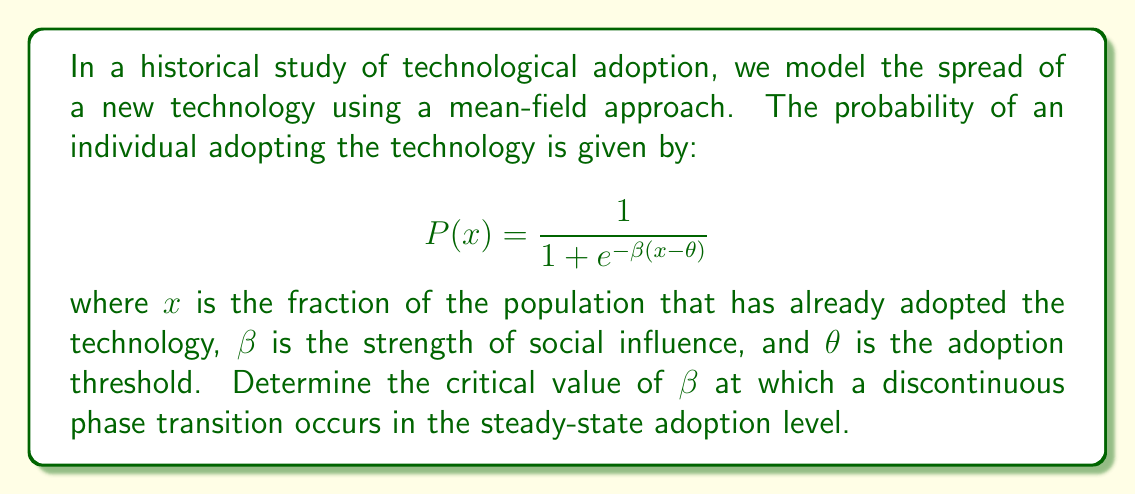Show me your answer to this math problem. To find the critical value of $\beta$, we follow these steps:

1) In the steady state, the fraction of adopters $x$ must satisfy:

   $$x = P(x) = \frac{1}{1 + e^{-\beta(x-\theta)}}$$

2) This equation can have multiple solutions, indicating a phase transition. To find the critical point, we need to find when the curve $y = P(x)$ just touches the line $y = x$.

3) This occurs when:
   
   $$\frac{dP}{dx} = 1$$

4) We calculate $\frac{dP}{dx}$:

   $$\frac{dP}{dx} = \frac{\beta e^{-\beta(x-\theta)}}{(1 + e^{-\beta(x-\theta)})^2}$$

5) At the critical point, this equals 1:

   $$\frac{\beta e^{-\beta(x-\theta)}}{(1 + e^{-\beta(x-\theta)})^2} = 1$$

6) This equation is satisfied when:

   $$e^{-\beta(x-\theta)} = 1$$

   Which implies $x = \theta$ at the critical point.

7) Substituting this back into the steady-state equation:

   $$\theta = \frac{1}{1 + e^{-\beta(\theta-\theta)}} = \frac{1}{2}$$

8) This means the critical point occurs at $\theta = \frac{1}{2}$.

9) Substituting $x = \theta = \frac{1}{2}$ into the equation from step 5:

   $$\frac{\beta}{4} = 1$$

10) Solving for $\beta$:

    $$\beta_{critical} = 4$$
Answer: $\beta_{critical} = 4$ 